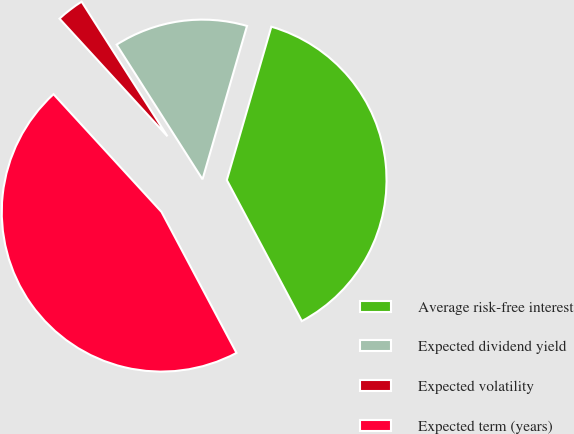Convert chart. <chart><loc_0><loc_0><loc_500><loc_500><pie_chart><fcel>Average risk-free interest<fcel>Expected dividend yield<fcel>Expected volatility<fcel>Expected term (years)<nl><fcel>37.73%<fcel>13.53%<fcel>2.78%<fcel>45.97%<nl></chart> 